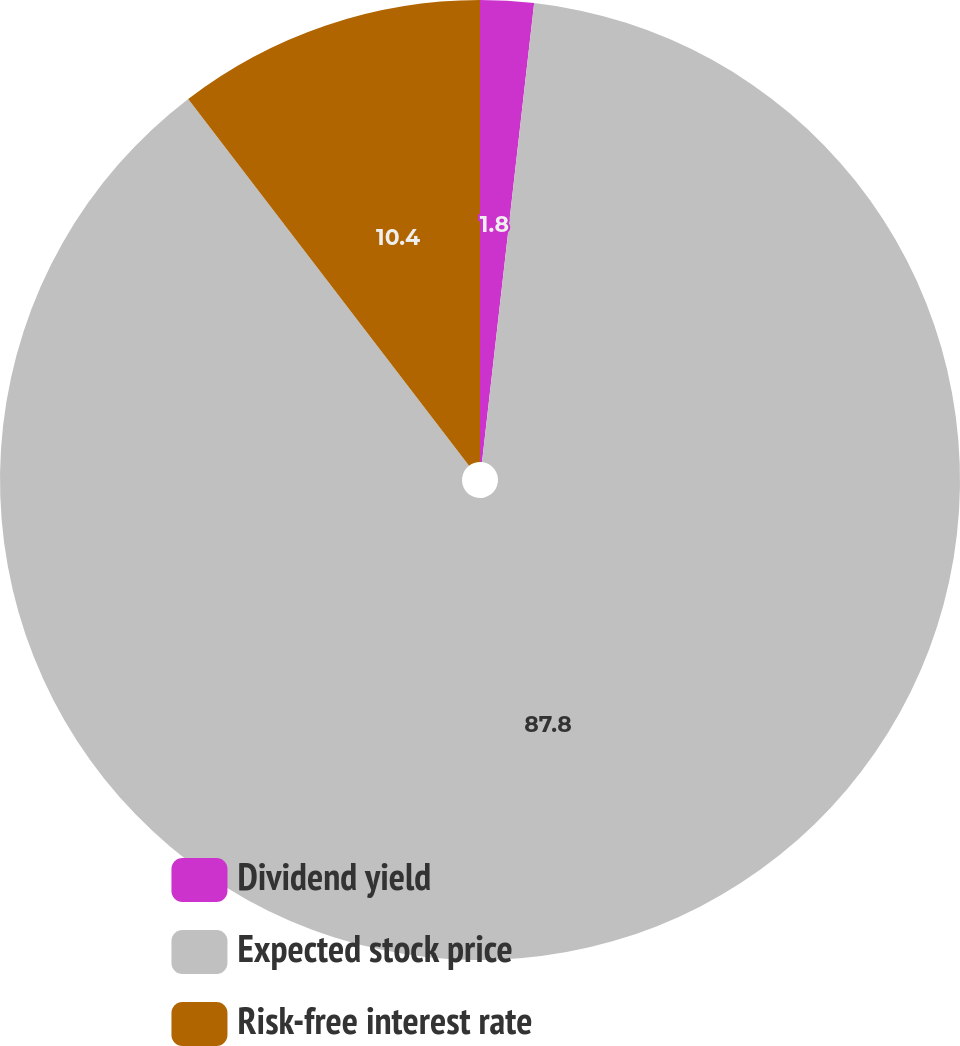Convert chart to OTSL. <chart><loc_0><loc_0><loc_500><loc_500><pie_chart><fcel>Dividend yield<fcel>Expected stock price<fcel>Risk-free interest rate<nl><fcel>1.8%<fcel>87.8%<fcel>10.4%<nl></chart> 